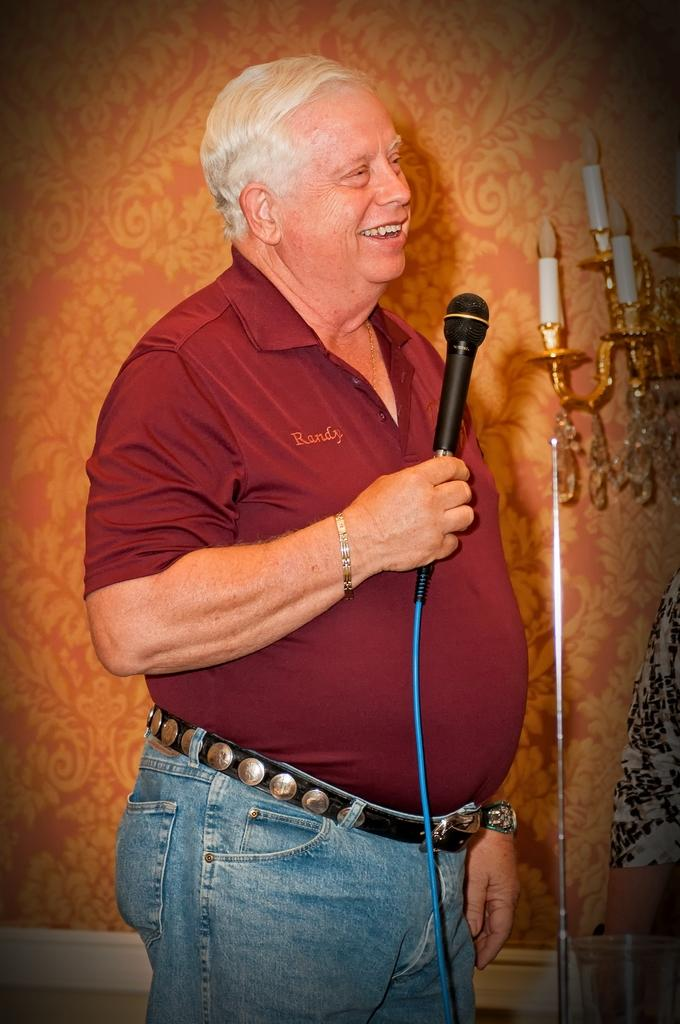Who is the main subject in the image? There is a man in the image. What is the man holding in the image? The man is holding a microphone. What can be seen behind the man in the image? There is a candle stand behind the man. What type of paste is being used to record the railway in the image? There is no paste, railway, or recording activity present in the image. 